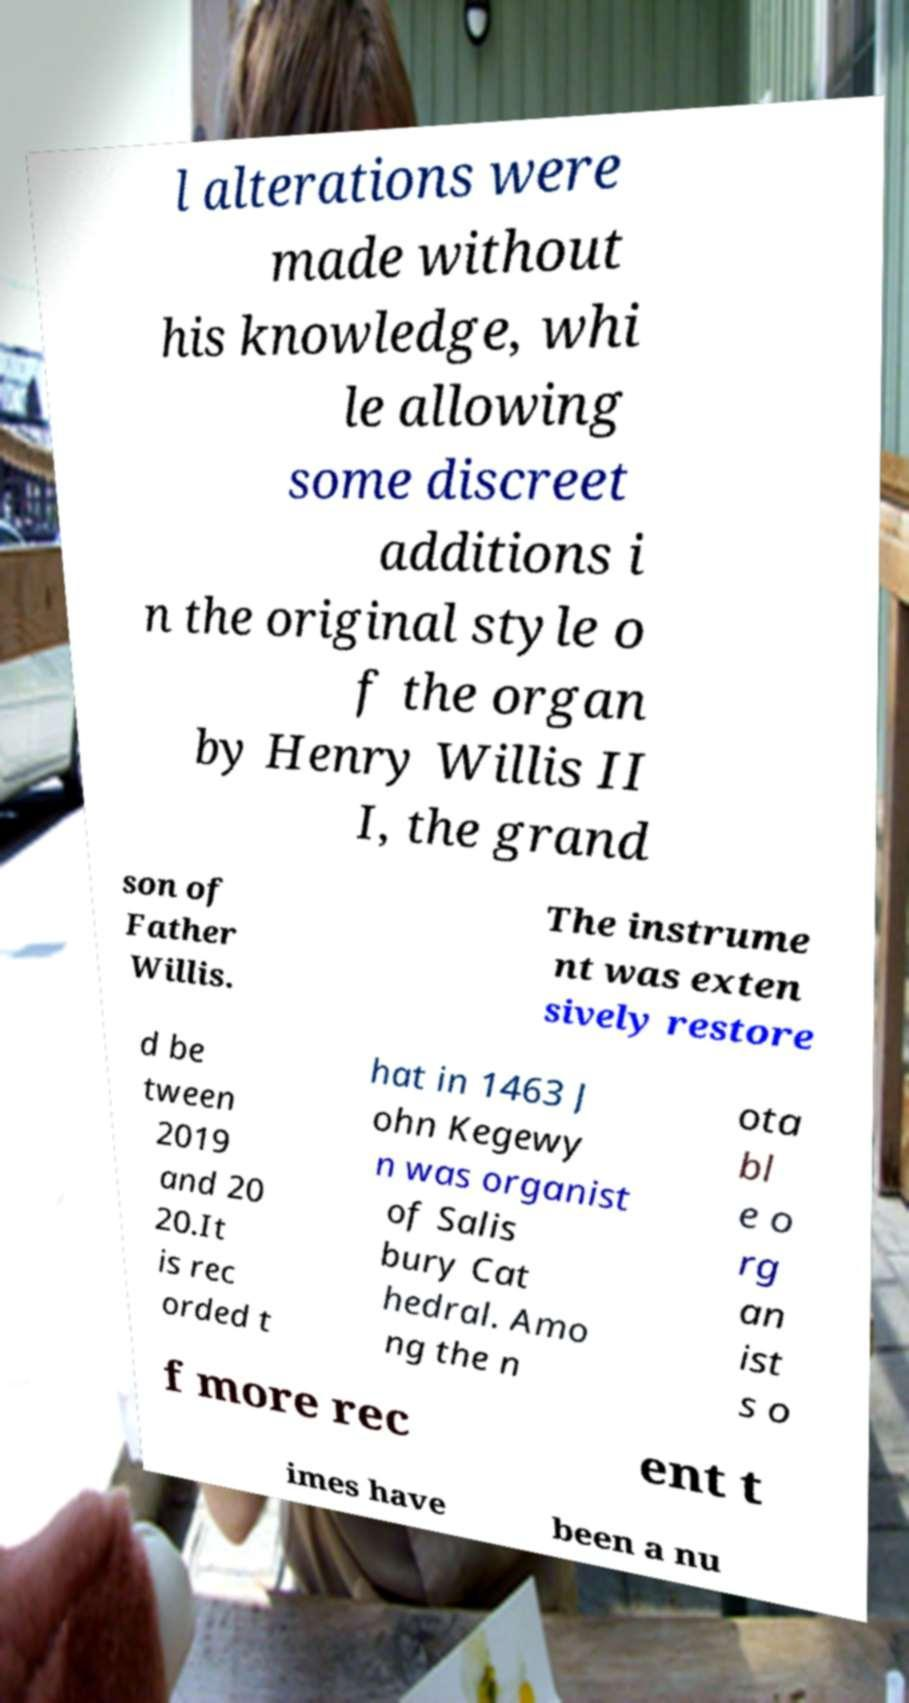Could you extract and type out the text from this image? l alterations were made without his knowledge, whi le allowing some discreet additions i n the original style o f the organ by Henry Willis II I, the grand son of Father Willis. The instrume nt was exten sively restore d be tween 2019 and 20 20.It is rec orded t hat in 1463 J ohn Kegewy n was organist of Salis bury Cat hedral. Amo ng the n ota bl e o rg an ist s o f more rec ent t imes have been a nu 